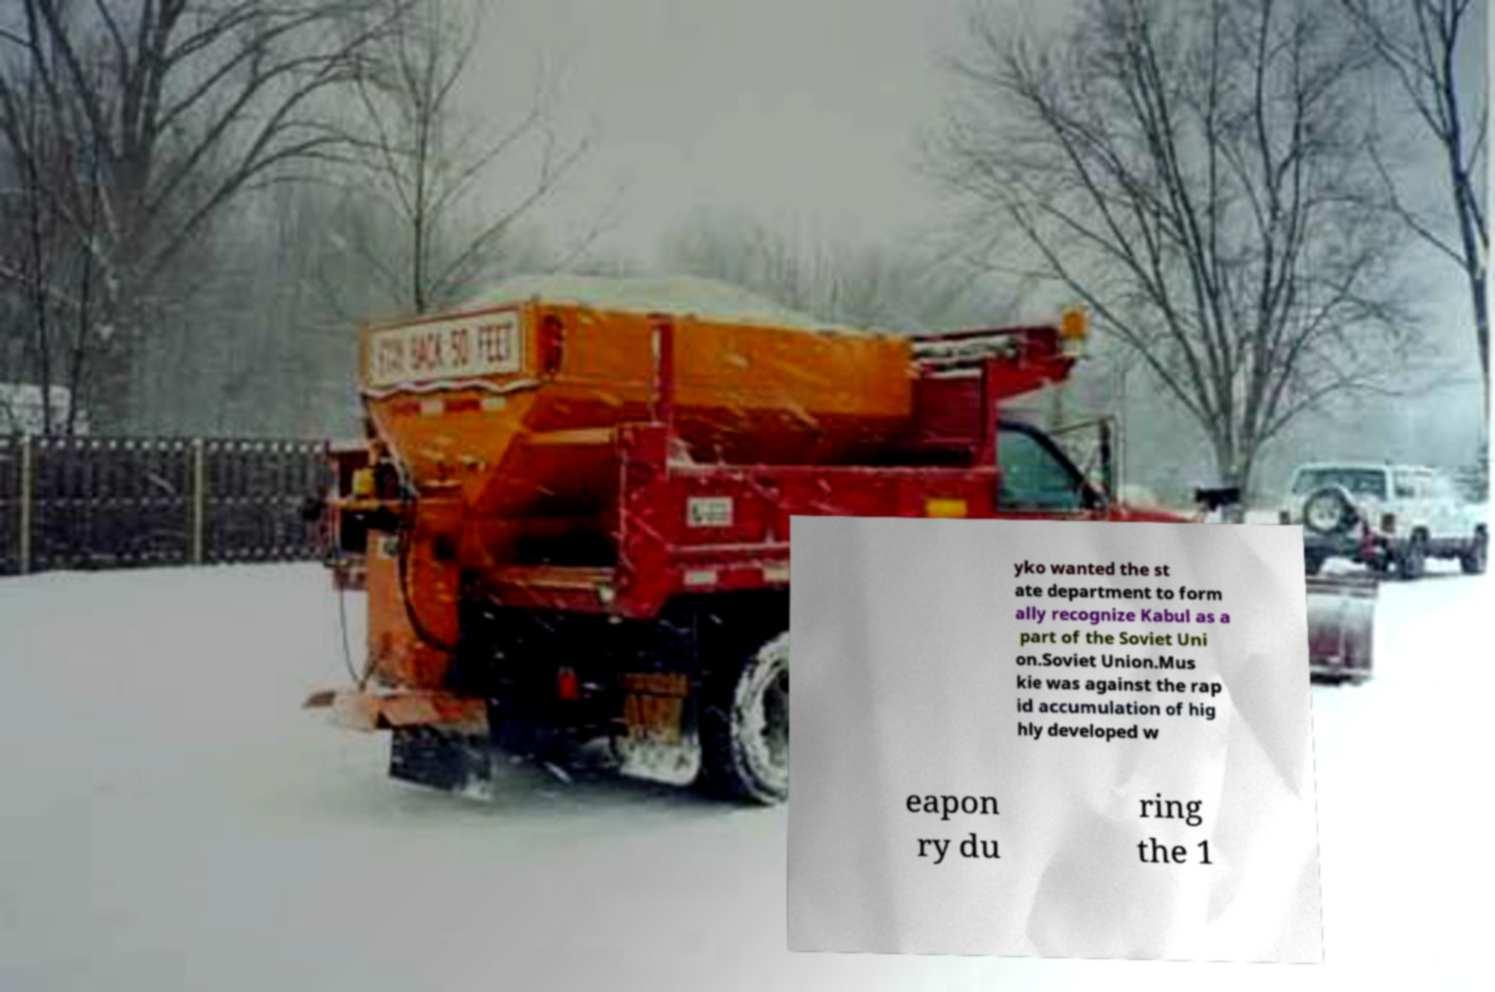Please read and relay the text visible in this image. What does it say? yko wanted the st ate department to form ally recognize Kabul as a part of the Soviet Uni on.Soviet Union.Mus kie was against the rap id accumulation of hig hly developed w eapon ry du ring the 1 